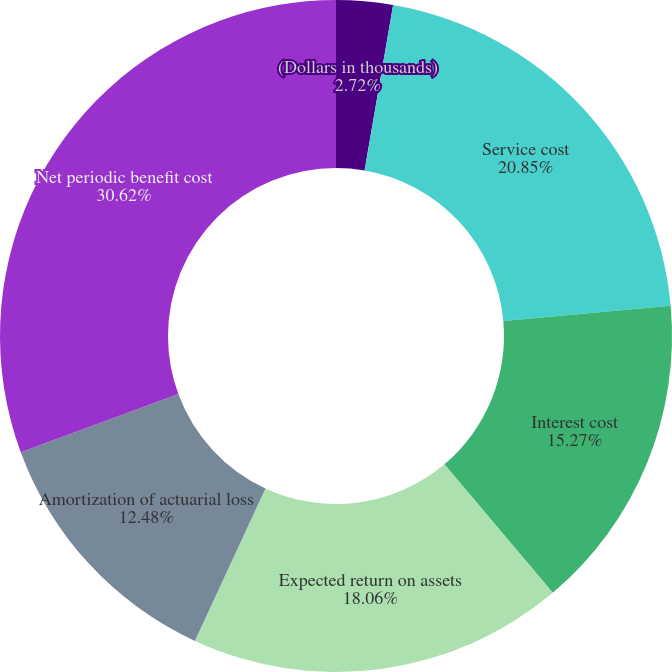<chart> <loc_0><loc_0><loc_500><loc_500><pie_chart><fcel>(Dollars in thousands)<fcel>Service cost<fcel>Interest cost<fcel>Expected return on assets<fcel>Amortization of actuarial loss<fcel>Net periodic benefit cost<nl><fcel>2.72%<fcel>20.85%<fcel>15.27%<fcel>18.06%<fcel>12.48%<fcel>30.62%<nl></chart> 